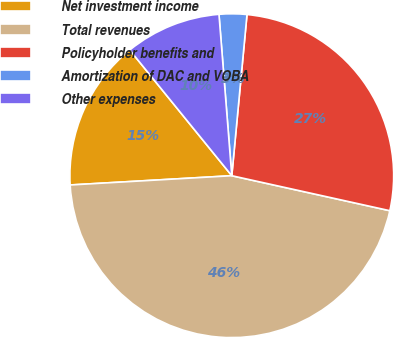Convert chart. <chart><loc_0><loc_0><loc_500><loc_500><pie_chart><fcel>Net investment income<fcel>Total revenues<fcel>Policyholder benefits and<fcel>Amortization of DAC and VOBA<fcel>Other expenses<nl><fcel>15.06%<fcel>45.62%<fcel>26.97%<fcel>2.76%<fcel>9.59%<nl></chart> 